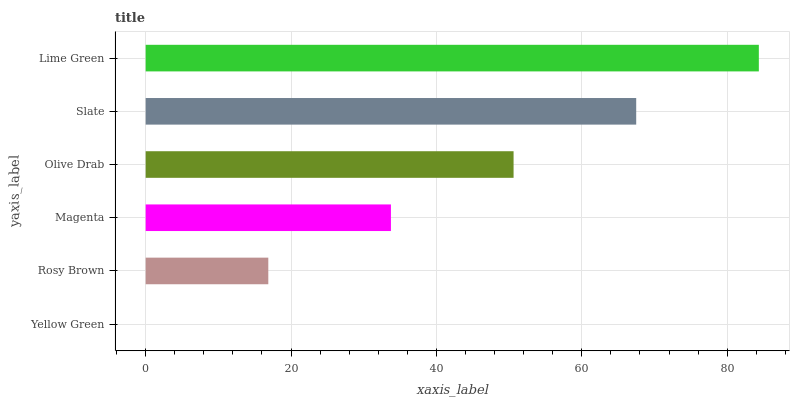Is Yellow Green the minimum?
Answer yes or no. Yes. Is Lime Green the maximum?
Answer yes or no. Yes. Is Rosy Brown the minimum?
Answer yes or no. No. Is Rosy Brown the maximum?
Answer yes or no. No. Is Rosy Brown greater than Yellow Green?
Answer yes or no. Yes. Is Yellow Green less than Rosy Brown?
Answer yes or no. Yes. Is Yellow Green greater than Rosy Brown?
Answer yes or no. No. Is Rosy Brown less than Yellow Green?
Answer yes or no. No. Is Olive Drab the high median?
Answer yes or no. Yes. Is Magenta the low median?
Answer yes or no. Yes. Is Magenta the high median?
Answer yes or no. No. Is Rosy Brown the low median?
Answer yes or no. No. 